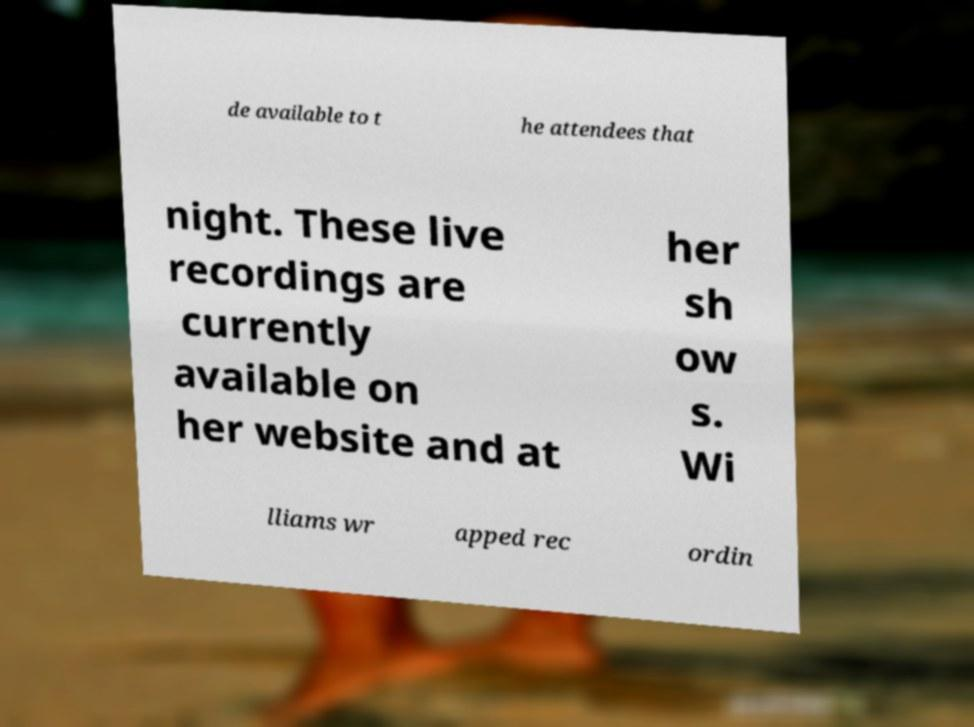Please identify and transcribe the text found in this image. de available to t he attendees that night. These live recordings are currently available on her website and at her sh ow s. Wi lliams wr apped rec ordin 